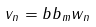Convert formula to latex. <formula><loc_0><loc_0><loc_500><loc_500>v _ { n } = b b _ { m } w _ { n }</formula> 